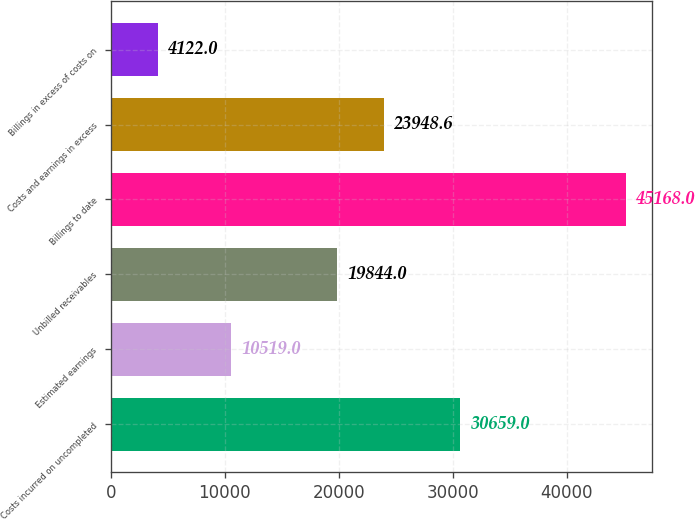<chart> <loc_0><loc_0><loc_500><loc_500><bar_chart><fcel>Costs incurred on uncompleted<fcel>Estimated earnings<fcel>Unbilled receivables<fcel>Billings to date<fcel>Costs and earnings in excess<fcel>Billings in excess of costs on<nl><fcel>30659<fcel>10519<fcel>19844<fcel>45168<fcel>23948.6<fcel>4122<nl></chart> 